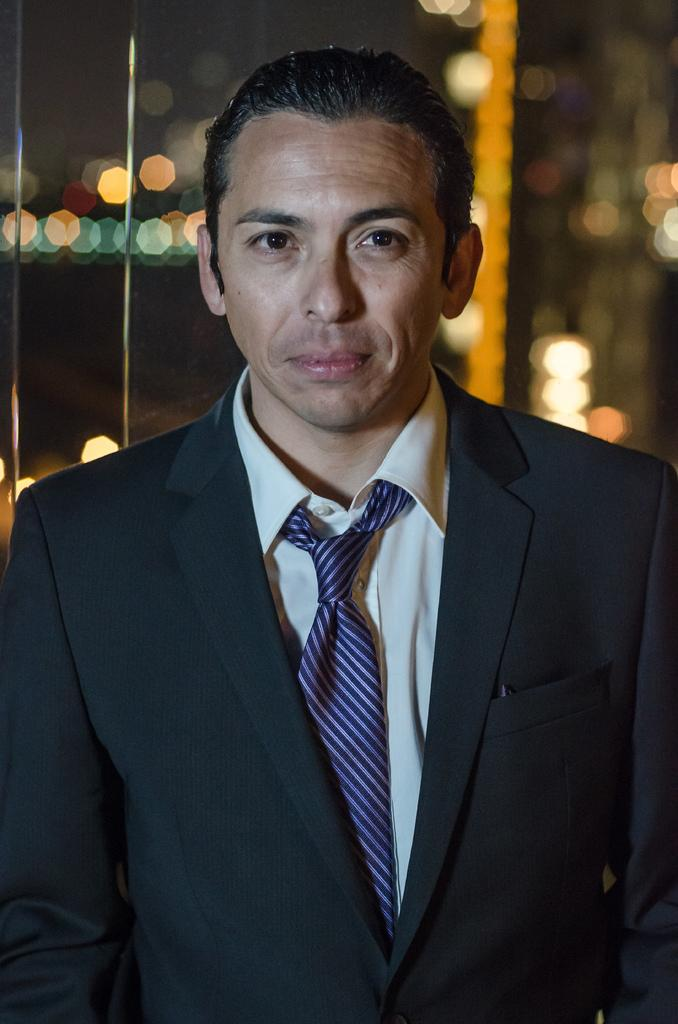What is the main subject of the image? There is a man standing in the middle of the image. What is the man's facial expression in the image? The man is smiling in the image. Can you describe the background of the image? The background of the image is blurred. What type of silver object is the man holding in the image? There is no silver object present in the image. Can you see a kitten playing with lettuce in the image? There is no kitten or lettuce present in the image. 